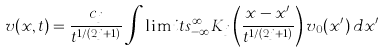Convert formula to latex. <formula><loc_0><loc_0><loc_500><loc_500>v ( x , t ) = \frac { c _ { j } } { t ^ { 1 / ( 2 j + 1 ) } } \int \lim i t s _ { - \infty } ^ { \infty } K _ { j } \left ( \frac { x - x ^ { \prime } } { t ^ { 1 / ( 2 j + 1 ) } } \right ) v _ { 0 } ( x ^ { \prime } ) \, d x ^ { \prime }</formula> 